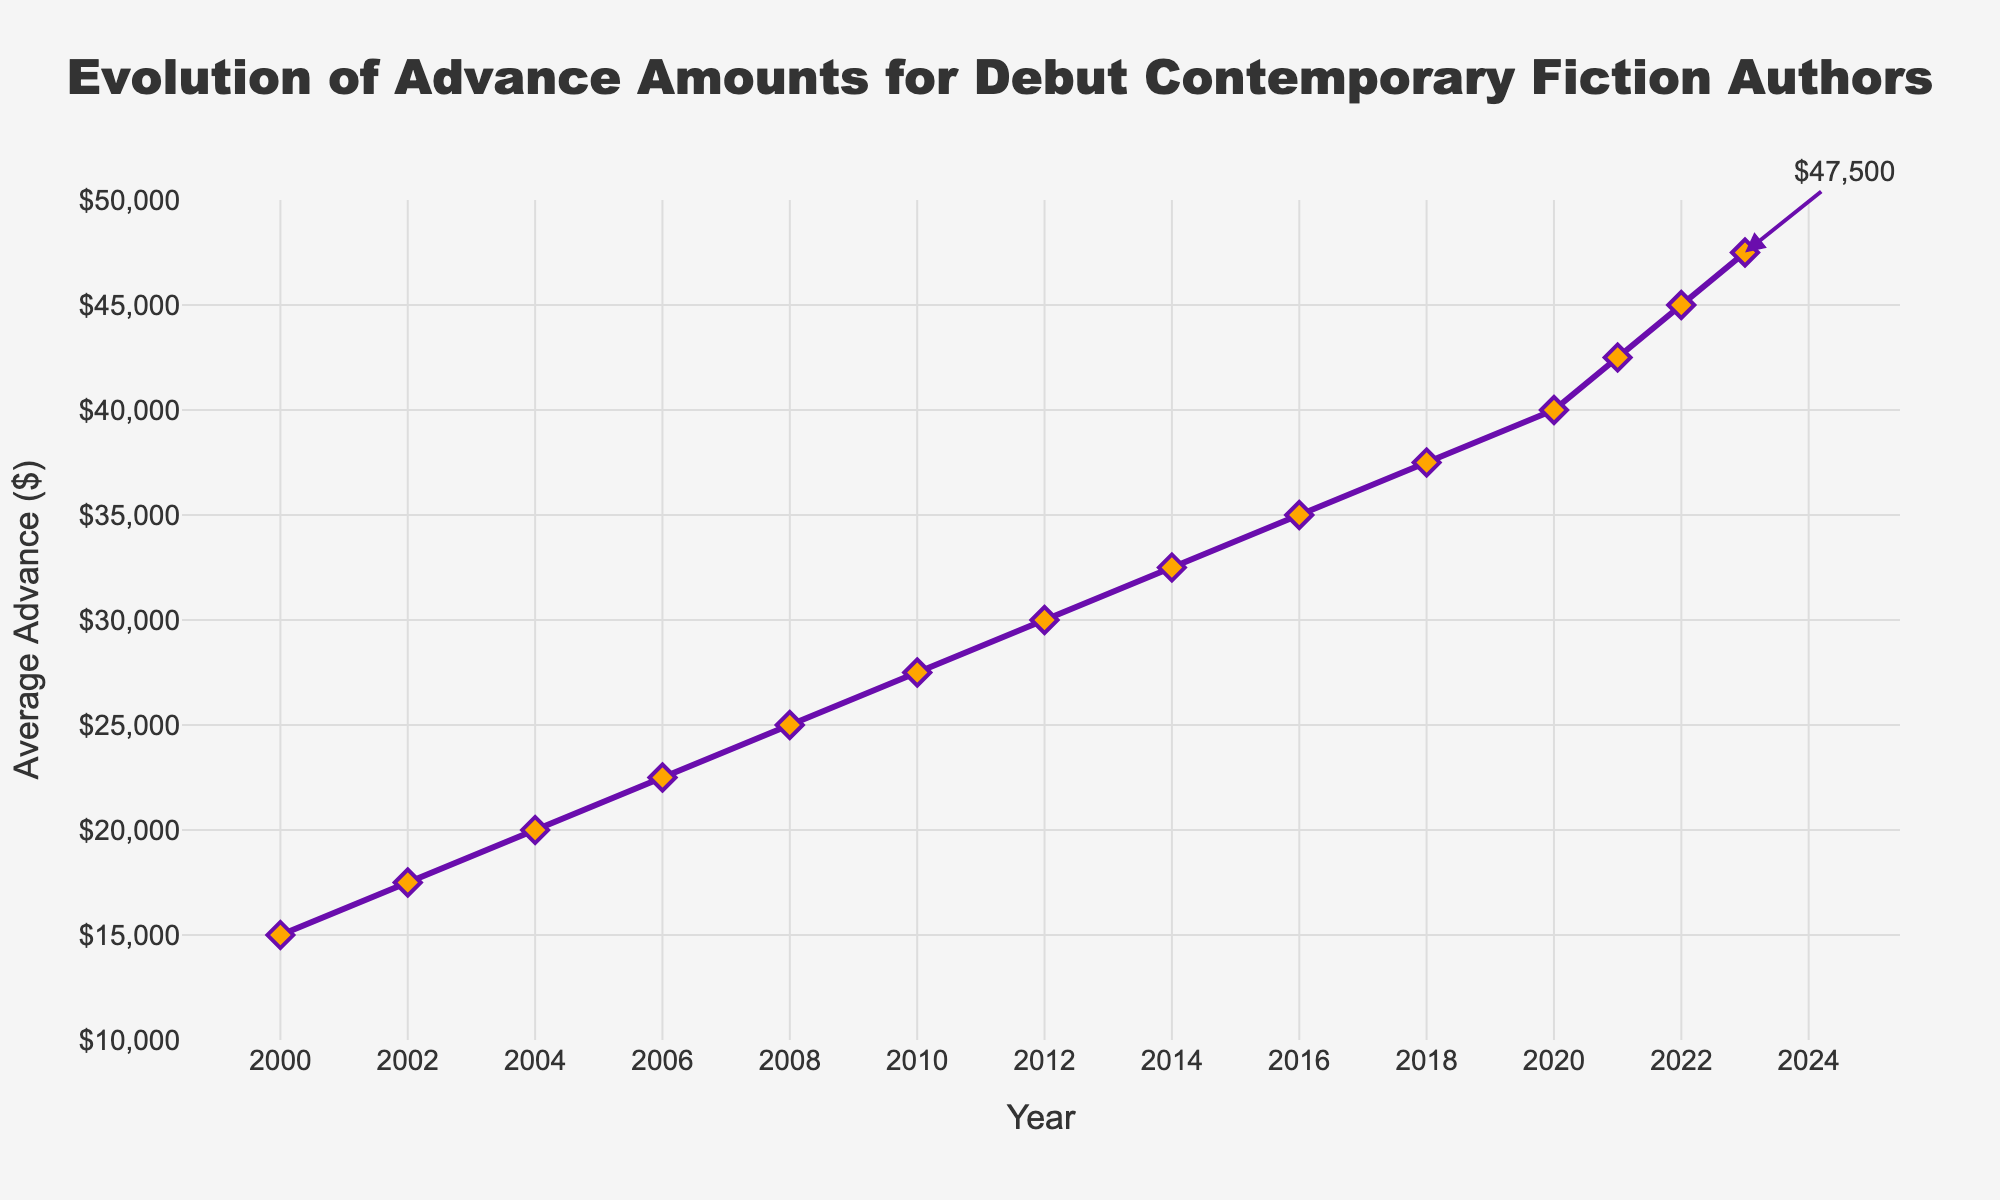what is the average advance amount in 2012? The plot shows the specific amount for each year. Locate the data point on the line for the year 2012.
Answer: 30000 Which year shows the highest average advance since 2000? Identify the highest data point on the y-axis from the line chart and note its corresponding year on the x-axis.
Answer: 2023 How much did the average advance increase between 2000 and 2023? Subtract the average advance amount in 2000 from the amount in 2023.
Answer: 32500 What is the general trend of the average advance amounts over the given period? Observe the overall direction of the line. It consistently moves upward from 2000 to 2023, indicating an increase every period.
Answer: Increasing Compare the average advances between 2006 and 2016. Identify the amounts for 2006 and 2016 from the chart and compare them: 22500 in 2006 and 35000 in 2016.
Answer: The average advance in 2016 is higher than in 2006 Calculate the average increase in advance amounts per year from 2000 to 2023. Divide the total increase (32500) by the number of periods (2023 - 2000 = 23 years).
Answer: 1413 What is the difference in average advances between 2010 and 2014? Subtract the amount in 2010 (27500) from the amount in 2014 (32500).
Answer: 5000 Between which consecutive two years was the largest increase in the average advance? Examine the differences between consecutive years' data points and find the largest one. From 2020 to 2021 (40000 to 42500), the increase is 2500.
Answer: 2020-2021 Are there any years where the average advance did not increase compared to the previous year? Observe the line for any flat sections or downward trends; in this chart, it always increases.
Answer: No Identify the color of the markers used in the chart. The visual attributes indicate that the markers' color is orange.
Answer: Orange 